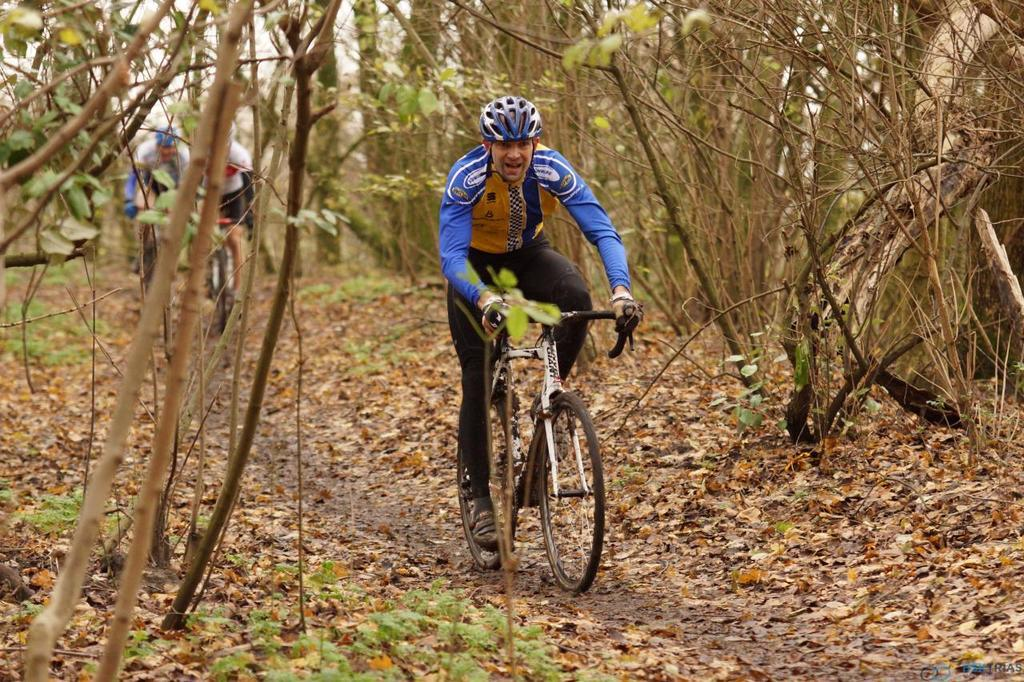What are the people in the image doing? The people in the image are riding bikes. What can be seen on the ground in the image? There are dry leaves on the ground in the image. What type of vegetation is visible in the image? There are trees visible in the image. What type of worm can be seen crawling on the credit card in the image? There is no worm or credit card present in the image. What nation is represented by the flag in the image? There is no flag present in the image. 